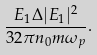<formula> <loc_0><loc_0><loc_500><loc_500>\frac { E _ { 1 } \Delta | E _ { 1 } | ^ { 2 } } { 3 2 \pi n _ { 0 } m \omega _ { p } } .</formula> 